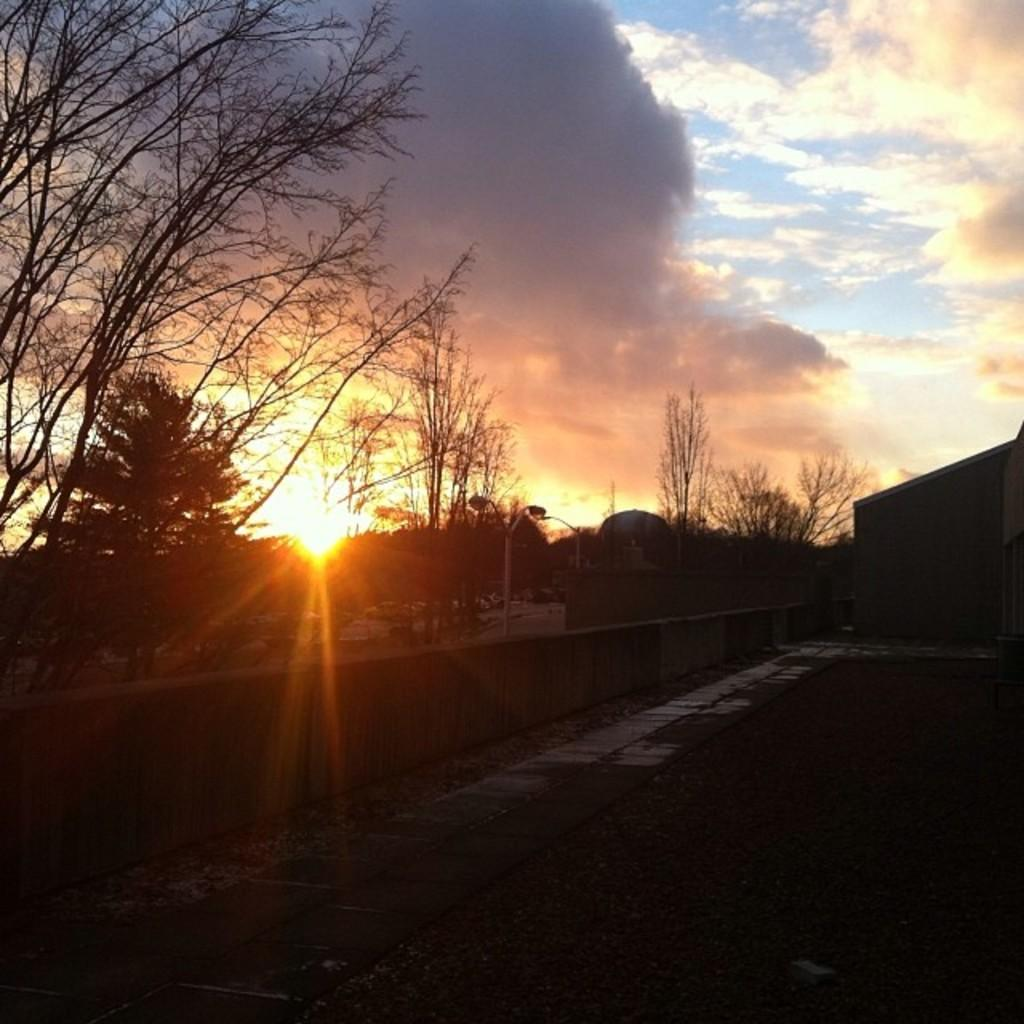What is the main object in the middle of the image? There is a street light pole in the middle of the image. What type of natural elements can be seen in the image? There are trees in the image. What is the condition of the sky in the image? The sky is cloudy in the image. What riddle can be solved using the wire in the image? There is no wire present in the image, so no riddle can be solved using it. 